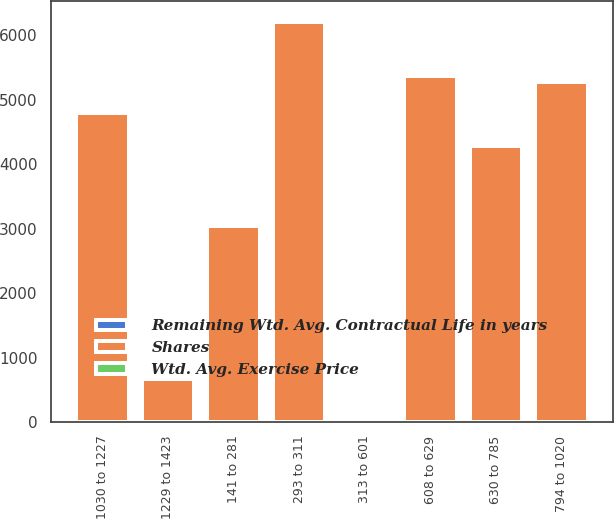Convert chart. <chart><loc_0><loc_0><loc_500><loc_500><stacked_bar_chart><ecel><fcel>141 to 281<fcel>293 to 311<fcel>313 to 601<fcel>608 to 629<fcel>630 to 785<fcel>794 to 1020<fcel>1030 to 1227<fcel>1229 to 1423<nl><fcel>Shares<fcel>3048<fcel>6205<fcel>8.5<fcel>5363<fcel>4277<fcel>5270<fcel>4783<fcel>666<nl><fcel>Wtd. Avg. Exercise Price<fcel>6.08<fcel>5<fcel>6.37<fcel>7.45<fcel>8.44<fcel>8.5<fcel>8.11<fcel>8.68<nl><fcel>Remaining Wtd. Avg. Contractual Life in years<fcel>1.88<fcel>3.11<fcel>4.89<fcel>6.25<fcel>7.19<fcel>9.79<fcel>11.97<fcel>13.36<nl></chart> 